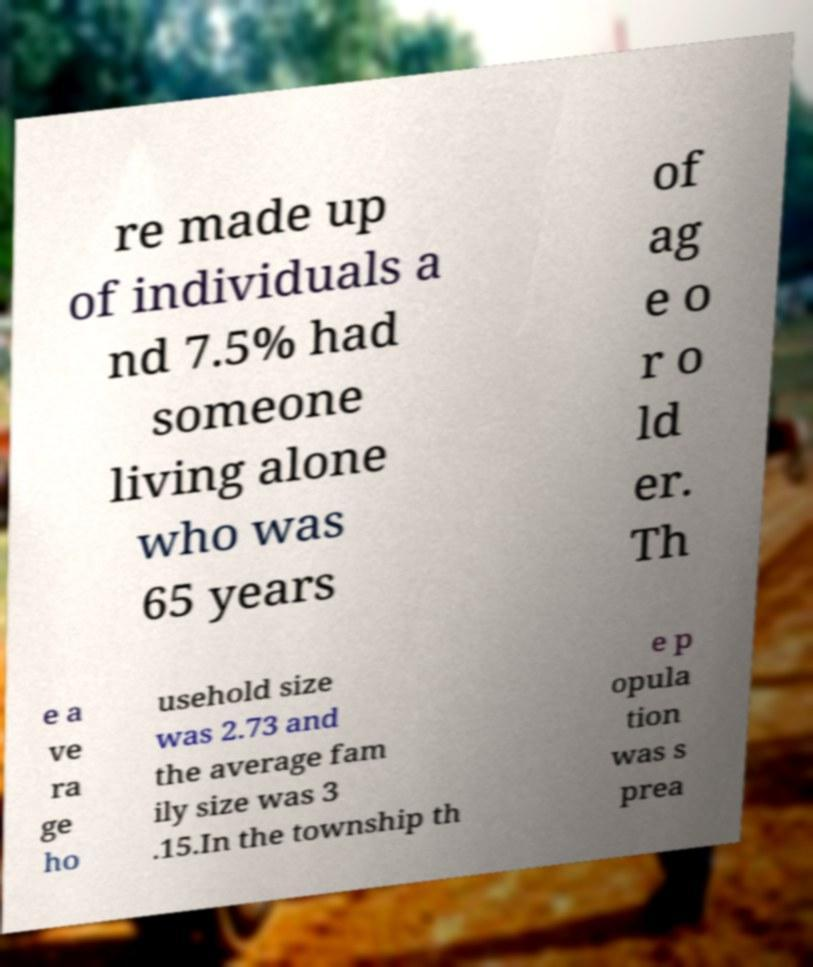Could you extract and type out the text from this image? re made up of individuals a nd 7.5% had someone living alone who was 65 years of ag e o r o ld er. Th e a ve ra ge ho usehold size was 2.73 and the average fam ily size was 3 .15.In the township th e p opula tion was s prea 